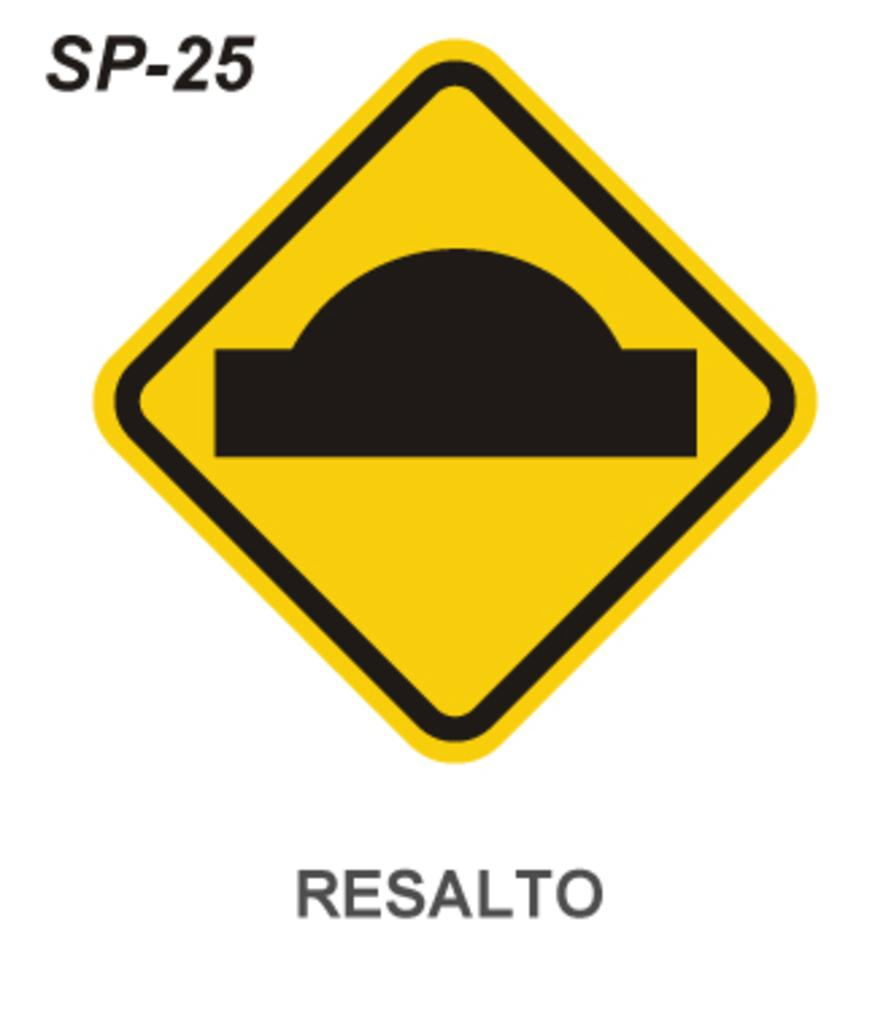<image>
Create a compact narrative representing the image presented. A yellow triangle road sign has the word resalto printed underneath it. 